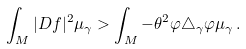<formula> <loc_0><loc_0><loc_500><loc_500>\int _ { M } | D f | ^ { 2 } \mu _ { \gamma } > \int _ { M } - \theta ^ { 2 } \varphi \triangle _ { \gamma } \varphi \mu _ { \gamma } \, .</formula> 